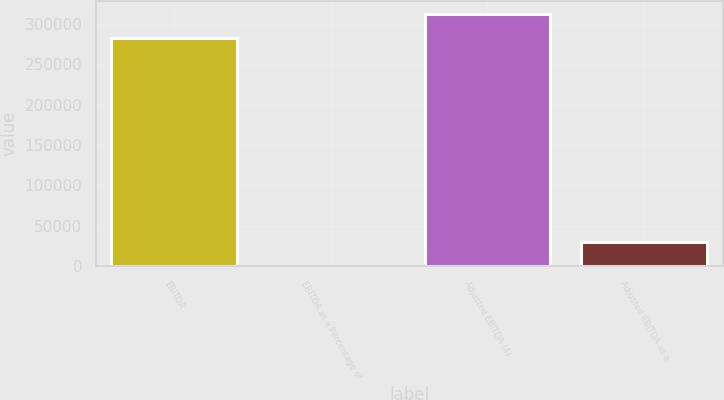Convert chart to OTSL. <chart><loc_0><loc_0><loc_500><loc_500><bar_chart><fcel>EBITDA<fcel>EBITDA as a Percentage of<fcel>Adjusted EBITDA (4)<fcel>Adjusted EBITDA as a<nl><fcel>282131<fcel>23.8<fcel>312353<fcel>30246<nl></chart> 